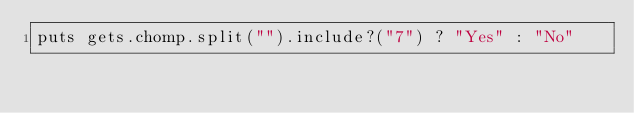Convert code to text. <code><loc_0><loc_0><loc_500><loc_500><_Ruby_>puts gets.chomp.split("").include?("7") ? "Yes" : "No"</code> 